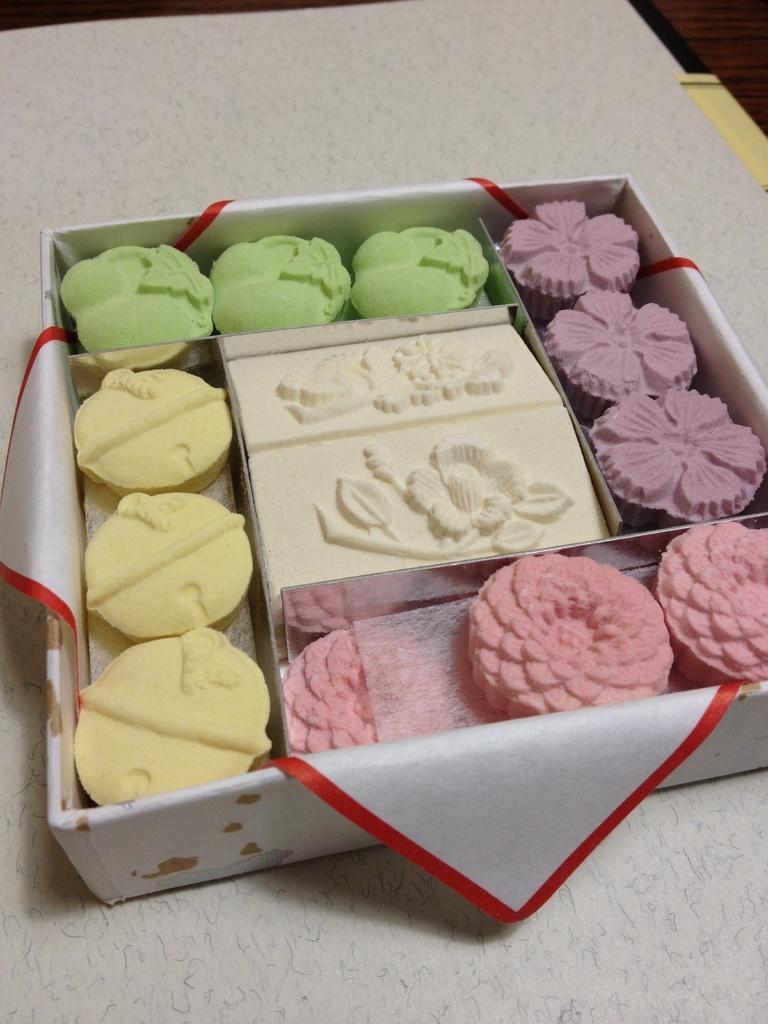Can you describe this image briefly? In this picture we can see a table. On the table we can see a box which contains desserts and paper. 